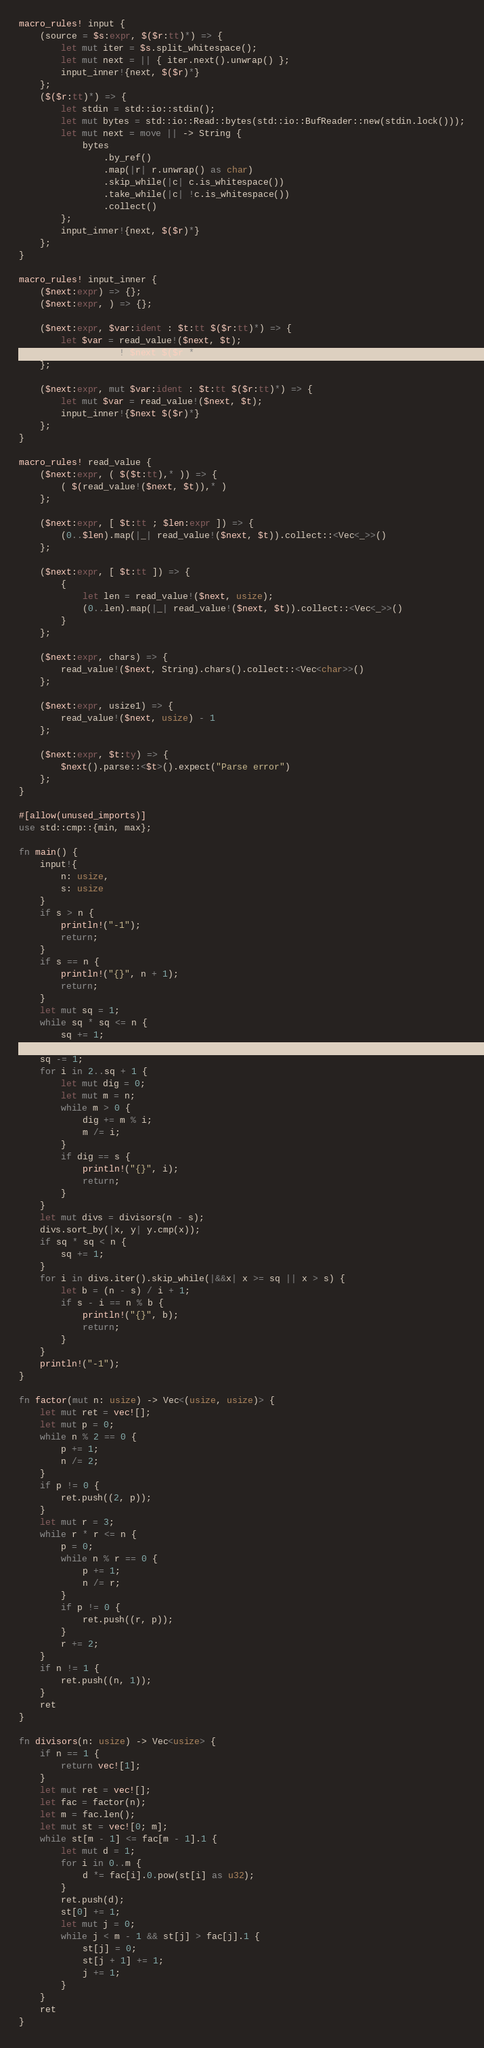Convert code to text. <code><loc_0><loc_0><loc_500><loc_500><_Rust_>macro_rules! input {
    (source = $s:expr, $($r:tt)*) => {
        let mut iter = $s.split_whitespace();
        let mut next = || { iter.next().unwrap() };
        input_inner!{next, $($r)*}
    };
    ($($r:tt)*) => {
        let stdin = std::io::stdin();
        let mut bytes = std::io::Read::bytes(std::io::BufReader::new(stdin.lock()));
        let mut next = move || -> String {
            bytes
                .by_ref()
                .map(|r| r.unwrap() as char)
                .skip_while(|c| c.is_whitespace())
                .take_while(|c| !c.is_whitespace())
                .collect()
        };
        input_inner!{next, $($r)*}
    };
}

macro_rules! input_inner {
    ($next:expr) => {};
    ($next:expr, ) => {};

    ($next:expr, $var:ident : $t:tt $($r:tt)*) => {
        let $var = read_value!($next, $t);
        input_inner!{$next $($r)*}
    };

    ($next:expr, mut $var:ident : $t:tt $($r:tt)*) => {
        let mut $var = read_value!($next, $t);
        input_inner!{$next $($r)*}
    };
}

macro_rules! read_value {
    ($next:expr, ( $($t:tt),* )) => {
        ( $(read_value!($next, $t)),* )
    };

    ($next:expr, [ $t:tt ; $len:expr ]) => {
        (0..$len).map(|_| read_value!($next, $t)).collect::<Vec<_>>()
    };

    ($next:expr, [ $t:tt ]) => {
        {
            let len = read_value!($next, usize);
            (0..len).map(|_| read_value!($next, $t)).collect::<Vec<_>>()
        }
    };

    ($next:expr, chars) => {
        read_value!($next, String).chars().collect::<Vec<char>>()
    };

    ($next:expr, usize1) => {
        read_value!($next, usize) - 1
    };

    ($next:expr, $t:ty) => {
        $next().parse::<$t>().expect("Parse error")
    };
}

#[allow(unused_imports)]
use std::cmp::{min, max};

fn main() {
    input!{
        n: usize,
        s: usize
    }
    if s > n {
        println!("-1");
        return;
    }
    if s == n {
        println!("{}", n + 1);
        return;
    }
    let mut sq = 1;
    while sq * sq <= n {
        sq += 1;
    }
    sq -= 1;
    for i in 2..sq + 1 {
        let mut dig = 0;
        let mut m = n;
        while m > 0 {
            dig += m % i;
            m /= i;
        }
        if dig == s {
            println!("{}", i);
            return;
        }
    }
    let mut divs = divisors(n - s);
    divs.sort_by(|x, y| y.cmp(x));
    if sq * sq < n {
        sq += 1;
    }
    for i in divs.iter().skip_while(|&&x| x >= sq || x > s) {
        let b = (n - s) / i + 1;
        if s - i == n % b {
            println!("{}", b);
            return;
        }
    }
    println!("-1");
}

fn factor(mut n: usize) -> Vec<(usize, usize)> {
    let mut ret = vec![];
    let mut p = 0;
    while n % 2 == 0 {
        p += 1;
        n /= 2;
    }
    if p != 0 {
        ret.push((2, p));
    }
    let mut r = 3;
    while r * r <= n {
        p = 0;
        while n % r == 0 {
            p += 1;
            n /= r;
        }
        if p != 0 {
            ret.push((r, p));
        }
        r += 2;
    }
    if n != 1 {
        ret.push((n, 1));
    }
    ret
}

fn divisors(n: usize) -> Vec<usize> {
    if n == 1 {
        return vec![1];
    }
    let mut ret = vec![];
    let fac = factor(n);
    let m = fac.len();
    let mut st = vec![0; m];
    while st[m - 1] <= fac[m - 1].1 {
        let mut d = 1;
        for i in 0..m {
            d *= fac[i].0.pow(st[i] as u32);
        }
        ret.push(d);
        st[0] += 1;
        let mut j = 0;
        while j < m - 1 && st[j] > fac[j].1 {
            st[j] = 0;
            st[j + 1] += 1;
            j += 1;
        }
    }
    ret
}
</code> 